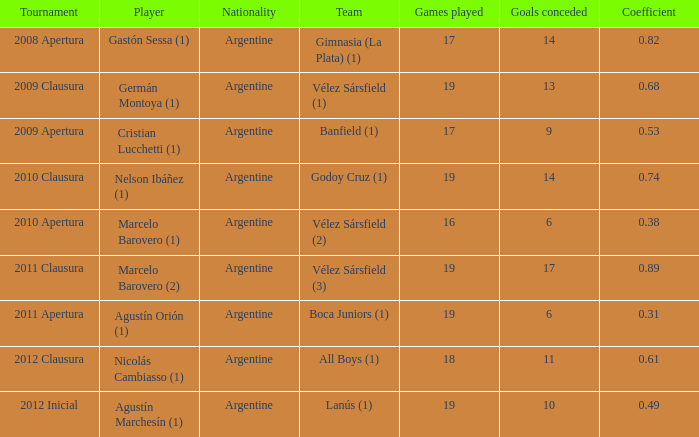The 2010 finale tournament? 0.74. 